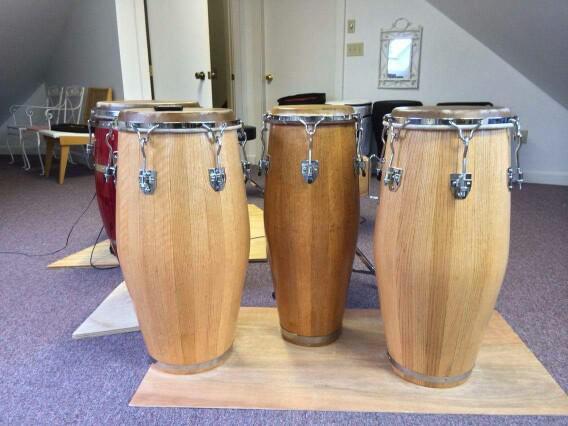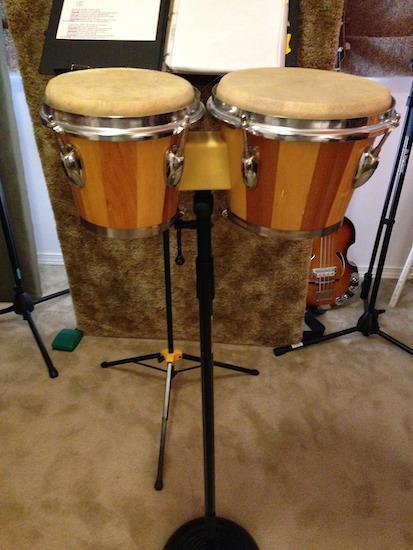The first image is the image on the left, the second image is the image on the right. Analyze the images presented: Is the assertion "There are a total of four drums." valid? Answer yes or no. No. The first image is the image on the left, the second image is the image on the right. For the images shown, is this caption "There are exactly two bongo drums." true? Answer yes or no. No. 